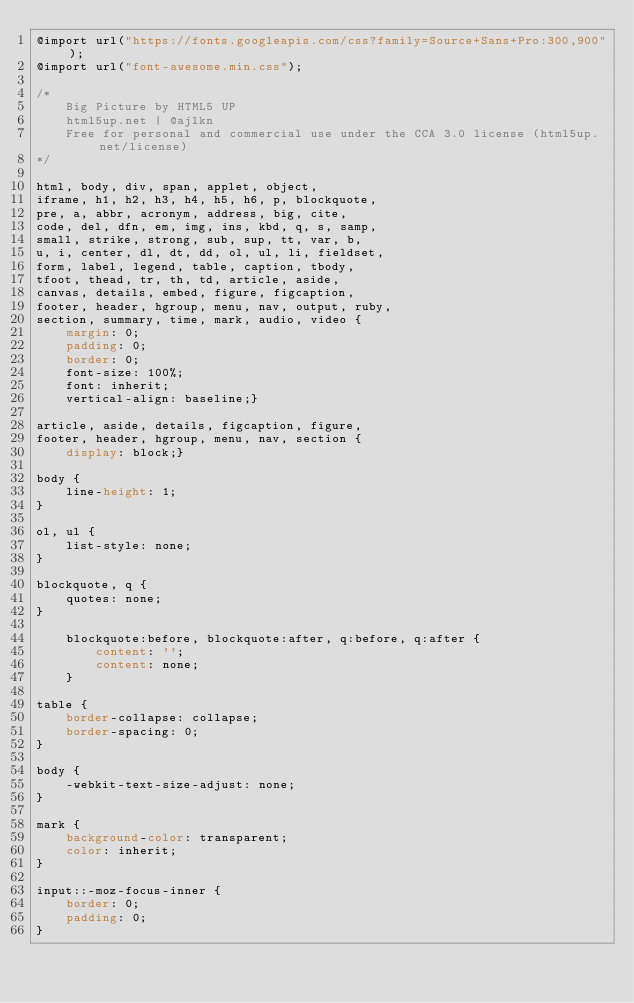<code> <loc_0><loc_0><loc_500><loc_500><_CSS_>@import url("https://fonts.googleapis.com/css?family=Source+Sans+Pro:300,900");
@import url("font-awesome.min.css");

/*
	Big Picture by HTML5 UP
	html5up.net | @ajlkn
	Free for personal and commercial use under the CCA 3.0 license (html5up.net/license)
*/

html, body, div, span, applet, object,
iframe, h1, h2, h3, h4, h5, h6, p, blockquote,
pre, a, abbr, acronym, address, big, cite,
code, del, dfn, em, img, ins, kbd, q, s, samp,
small, strike, strong, sub, sup, tt, var, b,
u, i, center, dl, dt, dd, ol, ul, li, fieldset,
form, label, legend, table, caption, tbody,
tfoot, thead, tr, th, td, article, aside,
canvas, details, embed, figure, figcaption,
footer, header, hgroup, menu, nav, output, ruby,
section, summary, time, mark, audio, video {
	margin: 0;
	padding: 0;
	border: 0;
	font-size: 100%;
	font: inherit;
	vertical-align: baseline;}

article, aside, details, figcaption, figure,
footer, header, hgroup, menu, nav, section {
	display: block;}

body {
	line-height: 1;
}

ol, ul {
	list-style: none;
}

blockquote, q {
	quotes: none;
}

	blockquote:before, blockquote:after, q:before, q:after {
		content: '';
		content: none;
	}

table {
	border-collapse: collapse;
	border-spacing: 0;
}

body {
	-webkit-text-size-adjust: none;
}

mark {
	background-color: transparent;
	color: inherit;
}

input::-moz-focus-inner {
	border: 0;
	padding: 0;
}
</code> 